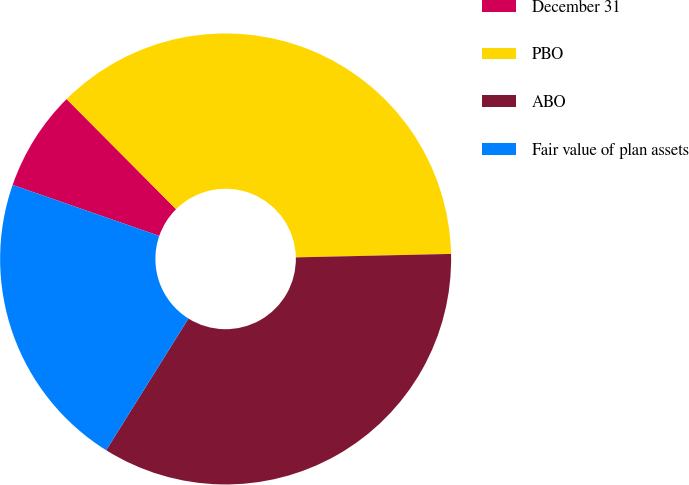Convert chart. <chart><loc_0><loc_0><loc_500><loc_500><pie_chart><fcel>December 31<fcel>PBO<fcel>ABO<fcel>Fair value of plan assets<nl><fcel>7.22%<fcel>37.1%<fcel>34.24%<fcel>21.44%<nl></chart> 